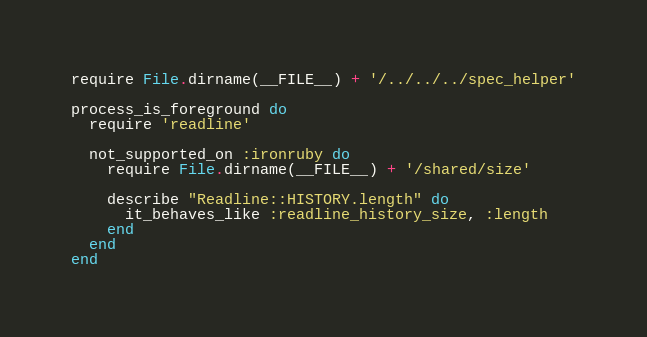Convert code to text. <code><loc_0><loc_0><loc_500><loc_500><_Ruby_>require File.dirname(__FILE__) + '/../../../spec_helper'

process_is_foreground do
  require 'readline'

  not_supported_on :ironruby do
    require File.dirname(__FILE__) + '/shared/size'

    describe "Readline::HISTORY.length" do
      it_behaves_like :readline_history_size, :length
    end
  end
end
</code> 